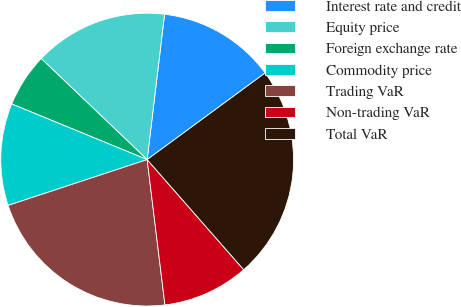Convert chart. <chart><loc_0><loc_0><loc_500><loc_500><pie_chart><fcel>Interest rate and credit<fcel>Equity price<fcel>Foreign exchange rate<fcel>Commodity price<fcel>Trading VaR<fcel>Non-trading VaR<fcel>Total VaR<nl><fcel>13.02%<fcel>14.77%<fcel>5.92%<fcel>11.27%<fcel>21.87%<fcel>9.52%<fcel>23.62%<nl></chart> 